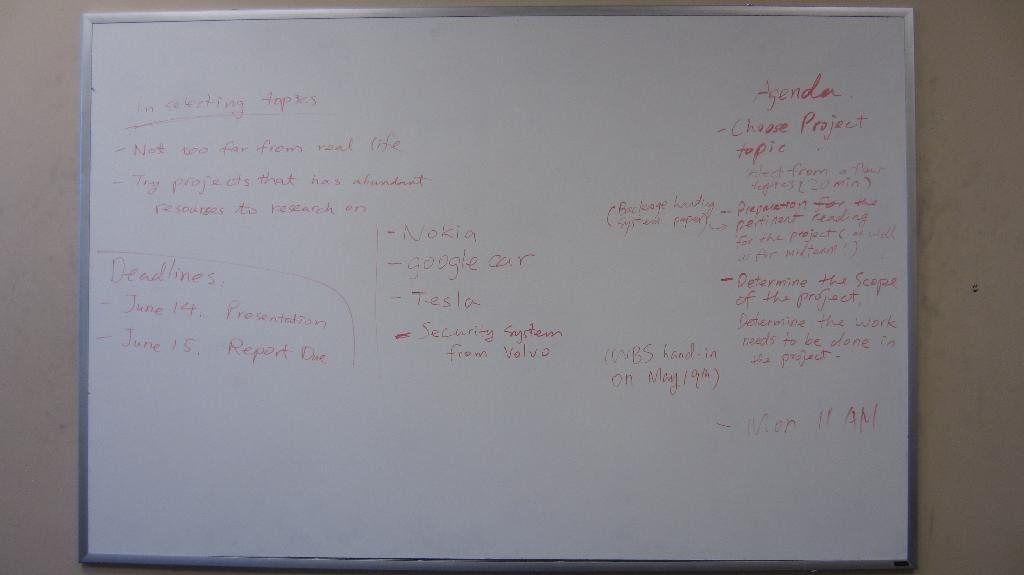<image>
Write a terse but informative summary of the picture. "Agenda" is written on a white board along with other words. 